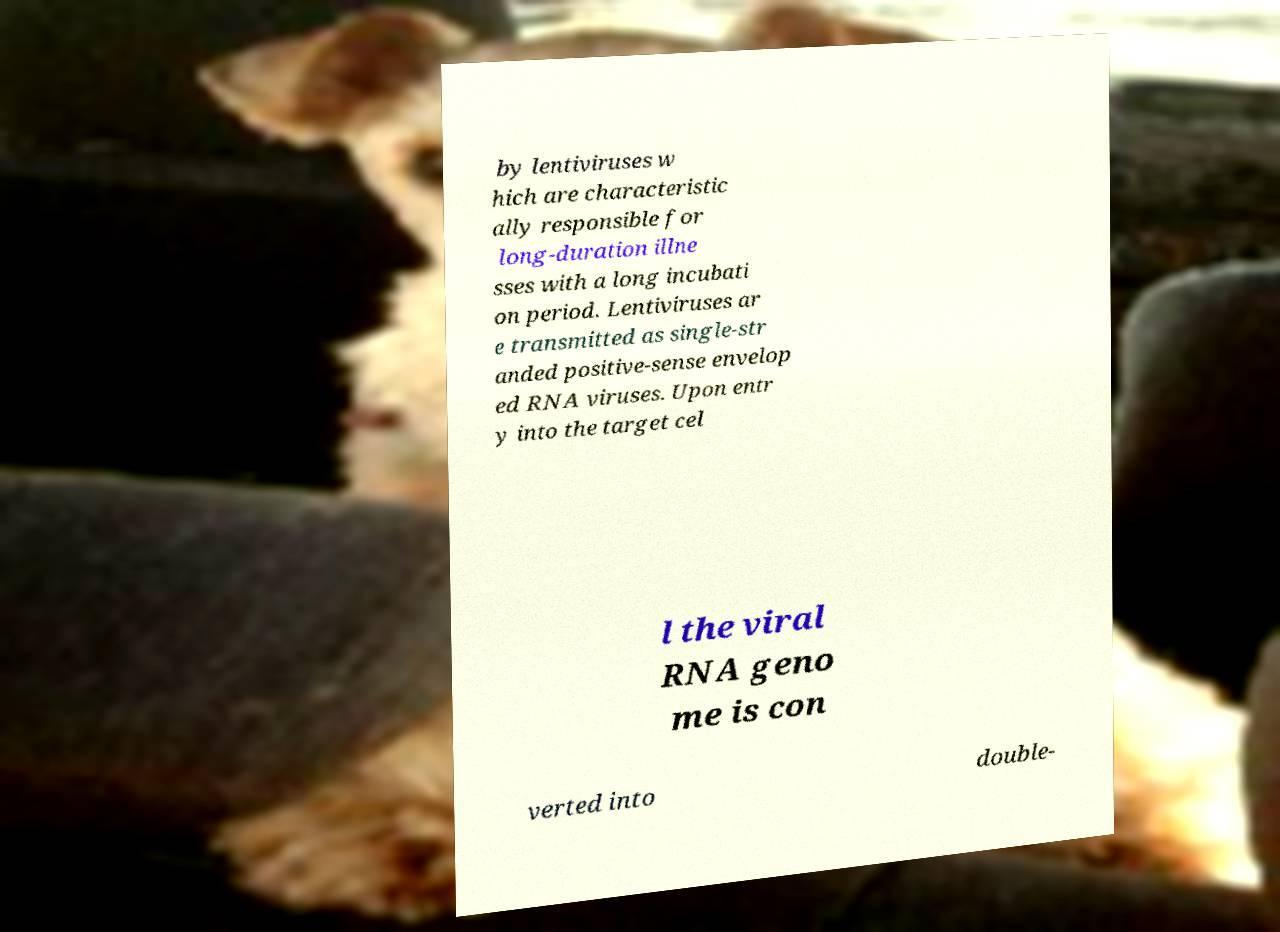What messages or text are displayed in this image? I need them in a readable, typed format. by lentiviruses w hich are characteristic ally responsible for long-duration illne sses with a long incubati on period. Lentiviruses ar e transmitted as single-str anded positive-sense envelop ed RNA viruses. Upon entr y into the target cel l the viral RNA geno me is con verted into double- 